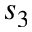<formula> <loc_0><loc_0><loc_500><loc_500>s _ { 3 }</formula> 